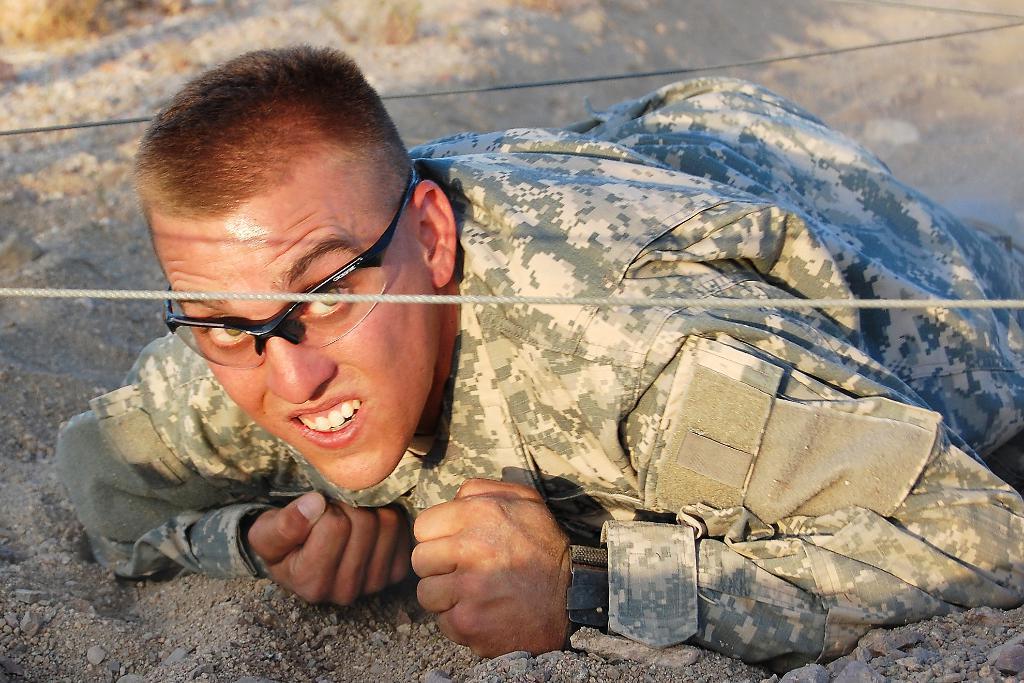Could you give a brief overview of what you see in this image? In this image, we can see a person in a military uniform is lying on the sand and watching. Here we can see ropes. 